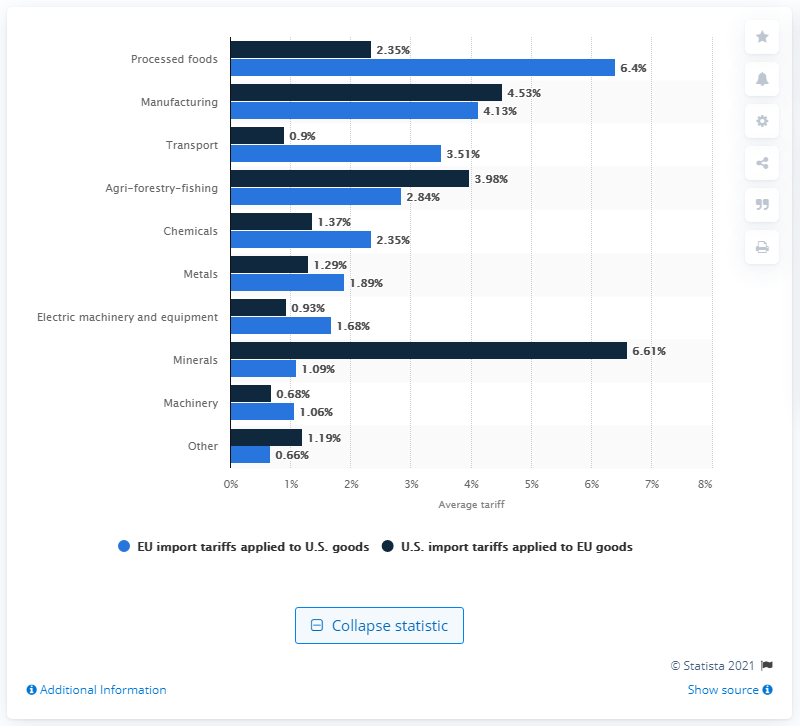Identify some key points in this picture. In 2013, the EU imposed a tariff of 6.4% on the importation of processed foods from the United States. 